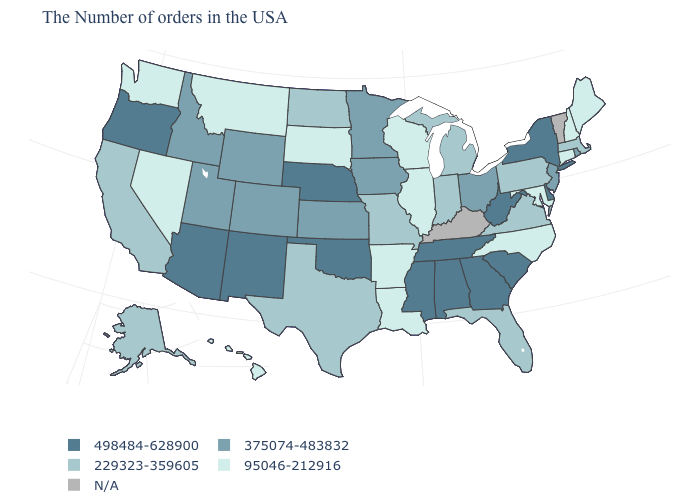Name the states that have a value in the range 229323-359605?
Quick response, please. Massachusetts, Pennsylvania, Virginia, Florida, Michigan, Indiana, Missouri, Texas, North Dakota, California, Alaska. Which states have the highest value in the USA?
Write a very short answer. New York, Delaware, South Carolina, West Virginia, Georgia, Alabama, Tennessee, Mississippi, Nebraska, Oklahoma, New Mexico, Arizona, Oregon. How many symbols are there in the legend?
Concise answer only. 5. Name the states that have a value in the range N/A?
Quick response, please. Vermont, Kentucky. How many symbols are there in the legend?
Answer briefly. 5. Name the states that have a value in the range 95046-212916?
Quick response, please. Maine, New Hampshire, Connecticut, Maryland, North Carolina, Wisconsin, Illinois, Louisiana, Arkansas, South Dakota, Montana, Nevada, Washington, Hawaii. What is the value of Massachusetts?
Answer briefly. 229323-359605. What is the value of Arizona?
Give a very brief answer. 498484-628900. Among the states that border Georgia , does North Carolina have the lowest value?
Keep it brief. Yes. How many symbols are there in the legend?
Write a very short answer. 5. What is the value of West Virginia?
Answer briefly. 498484-628900. What is the value of Connecticut?
Answer briefly. 95046-212916. Name the states that have a value in the range 95046-212916?
Give a very brief answer. Maine, New Hampshire, Connecticut, Maryland, North Carolina, Wisconsin, Illinois, Louisiana, Arkansas, South Dakota, Montana, Nevada, Washington, Hawaii. Name the states that have a value in the range 95046-212916?
Short answer required. Maine, New Hampshire, Connecticut, Maryland, North Carolina, Wisconsin, Illinois, Louisiana, Arkansas, South Dakota, Montana, Nevada, Washington, Hawaii. 